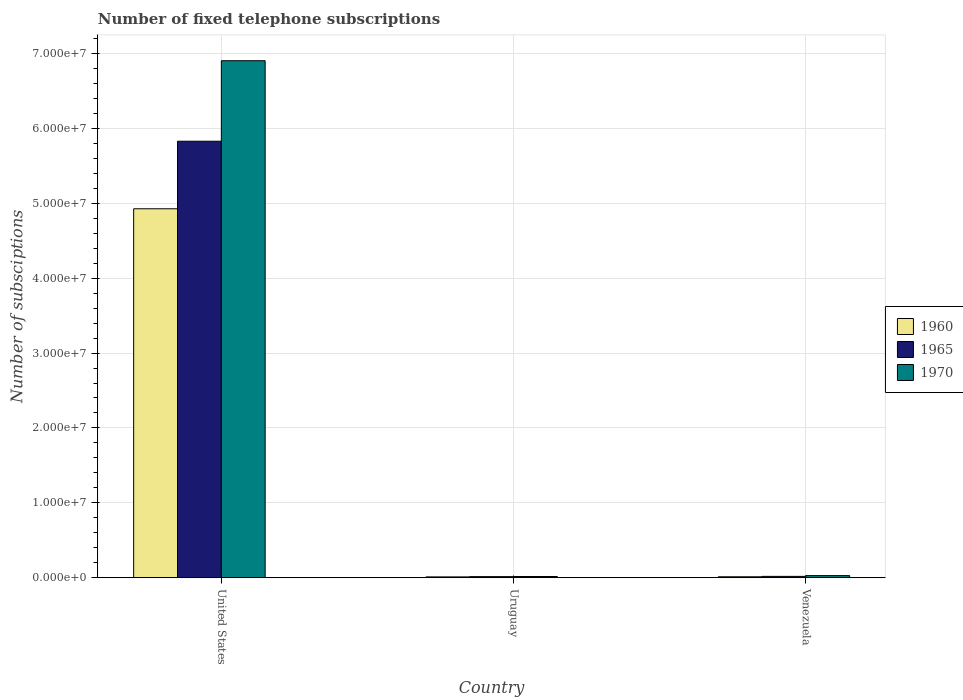How many different coloured bars are there?
Your answer should be very brief. 3. Are the number of bars per tick equal to the number of legend labels?
Give a very brief answer. Yes. Are the number of bars on each tick of the X-axis equal?
Your response must be concise. Yes. How many bars are there on the 3rd tick from the right?
Provide a short and direct response. 3. What is the label of the 2nd group of bars from the left?
Your response must be concise. Uruguay. In how many cases, is the number of bars for a given country not equal to the number of legend labels?
Provide a short and direct response. 0. What is the number of fixed telephone subscriptions in 1965 in Venezuela?
Offer a very short reply. 1.78e+05. Across all countries, what is the maximum number of fixed telephone subscriptions in 1965?
Your response must be concise. 5.83e+07. Across all countries, what is the minimum number of fixed telephone subscriptions in 1970?
Provide a succinct answer. 1.60e+05. In which country was the number of fixed telephone subscriptions in 1965 maximum?
Provide a succinct answer. United States. In which country was the number of fixed telephone subscriptions in 1970 minimum?
Ensure brevity in your answer.  Uruguay. What is the total number of fixed telephone subscriptions in 1970 in the graph?
Your answer should be very brief. 6.95e+07. What is the difference between the number of fixed telephone subscriptions in 1960 in United States and that in Uruguay?
Ensure brevity in your answer.  4.92e+07. What is the difference between the number of fixed telephone subscriptions in 1960 in Venezuela and the number of fixed telephone subscriptions in 1970 in United States?
Offer a very short reply. -6.89e+07. What is the average number of fixed telephone subscriptions in 1960 per country?
Your response must be concise. 1.65e+07. What is the difference between the number of fixed telephone subscriptions of/in 1970 and number of fixed telephone subscriptions of/in 1965 in Venezuela?
Ensure brevity in your answer.  1.01e+05. In how many countries, is the number of fixed telephone subscriptions in 1965 greater than 56000000?
Give a very brief answer. 1. What is the ratio of the number of fixed telephone subscriptions in 1965 in Uruguay to that in Venezuela?
Keep it short and to the point. 0.8. What is the difference between the highest and the second highest number of fixed telephone subscriptions in 1960?
Your answer should be compact. 4.91e+07. What is the difference between the highest and the lowest number of fixed telephone subscriptions in 1960?
Your answer should be very brief. 4.92e+07. What does the 2nd bar from the left in United States represents?
Offer a very short reply. 1965. What does the 3rd bar from the right in Venezuela represents?
Offer a terse response. 1960. Is it the case that in every country, the sum of the number of fixed telephone subscriptions in 1970 and number of fixed telephone subscriptions in 1960 is greater than the number of fixed telephone subscriptions in 1965?
Your answer should be very brief. Yes. How many countries are there in the graph?
Keep it short and to the point. 3. Are the values on the major ticks of Y-axis written in scientific E-notation?
Keep it short and to the point. Yes. Where does the legend appear in the graph?
Your answer should be compact. Center right. What is the title of the graph?
Your response must be concise. Number of fixed telephone subscriptions. Does "2002" appear as one of the legend labels in the graph?
Your answer should be very brief. No. What is the label or title of the X-axis?
Your answer should be very brief. Country. What is the label or title of the Y-axis?
Provide a succinct answer. Number of subsciptions. What is the Number of subsciptions in 1960 in United States?
Your response must be concise. 4.93e+07. What is the Number of subsciptions of 1965 in United States?
Keep it short and to the point. 5.83e+07. What is the Number of subsciptions in 1970 in United States?
Offer a very short reply. 6.90e+07. What is the Number of subsciptions of 1960 in Uruguay?
Ensure brevity in your answer.  1.10e+05. What is the Number of subsciptions of 1965 in Uruguay?
Ensure brevity in your answer.  1.42e+05. What is the Number of subsciptions of 1970 in Uruguay?
Ensure brevity in your answer.  1.60e+05. What is the Number of subsciptions in 1960 in Venezuela?
Your answer should be very brief. 1.25e+05. What is the Number of subsciptions in 1965 in Venezuela?
Offer a very short reply. 1.78e+05. What is the Number of subsciptions of 1970 in Venezuela?
Offer a terse response. 2.79e+05. Across all countries, what is the maximum Number of subsciptions of 1960?
Provide a short and direct response. 4.93e+07. Across all countries, what is the maximum Number of subsciptions of 1965?
Ensure brevity in your answer.  5.83e+07. Across all countries, what is the maximum Number of subsciptions in 1970?
Ensure brevity in your answer.  6.90e+07. Across all countries, what is the minimum Number of subsciptions in 1960?
Ensure brevity in your answer.  1.10e+05. Across all countries, what is the minimum Number of subsciptions of 1965?
Provide a succinct answer. 1.42e+05. What is the total Number of subsciptions in 1960 in the graph?
Your answer should be very brief. 4.95e+07. What is the total Number of subsciptions in 1965 in the graph?
Provide a short and direct response. 5.86e+07. What is the total Number of subsciptions in 1970 in the graph?
Provide a short and direct response. 6.95e+07. What is the difference between the Number of subsciptions of 1960 in United States and that in Uruguay?
Provide a short and direct response. 4.92e+07. What is the difference between the Number of subsciptions in 1965 in United States and that in Uruguay?
Provide a succinct answer. 5.81e+07. What is the difference between the Number of subsciptions of 1970 in United States and that in Uruguay?
Your response must be concise. 6.89e+07. What is the difference between the Number of subsciptions in 1960 in United States and that in Venezuela?
Offer a terse response. 4.91e+07. What is the difference between the Number of subsciptions in 1965 in United States and that in Venezuela?
Offer a very short reply. 5.81e+07. What is the difference between the Number of subsciptions of 1970 in United States and that in Venezuela?
Give a very brief answer. 6.88e+07. What is the difference between the Number of subsciptions in 1960 in Uruguay and that in Venezuela?
Your response must be concise. -1.50e+04. What is the difference between the Number of subsciptions of 1965 in Uruguay and that in Venezuela?
Offer a very short reply. -3.60e+04. What is the difference between the Number of subsciptions in 1970 in Uruguay and that in Venezuela?
Offer a very short reply. -1.19e+05. What is the difference between the Number of subsciptions in 1960 in United States and the Number of subsciptions in 1965 in Uruguay?
Provide a short and direct response. 4.91e+07. What is the difference between the Number of subsciptions of 1960 in United States and the Number of subsciptions of 1970 in Uruguay?
Your response must be concise. 4.91e+07. What is the difference between the Number of subsciptions in 1965 in United States and the Number of subsciptions in 1970 in Uruguay?
Your answer should be compact. 5.81e+07. What is the difference between the Number of subsciptions of 1960 in United States and the Number of subsciptions of 1965 in Venezuela?
Offer a very short reply. 4.91e+07. What is the difference between the Number of subsciptions in 1960 in United States and the Number of subsciptions in 1970 in Venezuela?
Give a very brief answer. 4.90e+07. What is the difference between the Number of subsciptions of 1965 in United States and the Number of subsciptions of 1970 in Venezuela?
Your answer should be compact. 5.80e+07. What is the difference between the Number of subsciptions of 1960 in Uruguay and the Number of subsciptions of 1965 in Venezuela?
Offer a terse response. -6.80e+04. What is the difference between the Number of subsciptions in 1960 in Uruguay and the Number of subsciptions in 1970 in Venezuela?
Offer a very short reply. -1.69e+05. What is the difference between the Number of subsciptions in 1965 in Uruguay and the Number of subsciptions in 1970 in Venezuela?
Give a very brief answer. -1.37e+05. What is the average Number of subsciptions in 1960 per country?
Keep it short and to the point. 1.65e+07. What is the average Number of subsciptions in 1965 per country?
Offer a terse response. 1.95e+07. What is the average Number of subsciptions in 1970 per country?
Offer a very short reply. 2.32e+07. What is the difference between the Number of subsciptions of 1960 and Number of subsciptions of 1965 in United States?
Make the answer very short. -9.02e+06. What is the difference between the Number of subsciptions in 1960 and Number of subsciptions in 1970 in United States?
Offer a very short reply. -1.98e+07. What is the difference between the Number of subsciptions of 1965 and Number of subsciptions of 1970 in United States?
Your answer should be very brief. -1.08e+07. What is the difference between the Number of subsciptions of 1960 and Number of subsciptions of 1965 in Uruguay?
Provide a succinct answer. -3.20e+04. What is the difference between the Number of subsciptions in 1960 and Number of subsciptions in 1970 in Uruguay?
Ensure brevity in your answer.  -5.00e+04. What is the difference between the Number of subsciptions of 1965 and Number of subsciptions of 1970 in Uruguay?
Offer a terse response. -1.80e+04. What is the difference between the Number of subsciptions of 1960 and Number of subsciptions of 1965 in Venezuela?
Your answer should be very brief. -5.30e+04. What is the difference between the Number of subsciptions of 1960 and Number of subsciptions of 1970 in Venezuela?
Your answer should be compact. -1.54e+05. What is the difference between the Number of subsciptions of 1965 and Number of subsciptions of 1970 in Venezuela?
Give a very brief answer. -1.01e+05. What is the ratio of the Number of subsciptions of 1960 in United States to that in Uruguay?
Offer a terse response. 447.9. What is the ratio of the Number of subsciptions of 1965 in United States to that in Uruguay?
Keep it short and to the point. 410.49. What is the ratio of the Number of subsciptions of 1970 in United States to that in Uruguay?
Your response must be concise. 431.49. What is the ratio of the Number of subsciptions of 1960 in United States to that in Venezuela?
Give a very brief answer. 394.15. What is the ratio of the Number of subsciptions of 1965 in United States to that in Venezuela?
Give a very brief answer. 327.47. What is the ratio of the Number of subsciptions of 1970 in United States to that in Venezuela?
Provide a short and direct response. 247.45. What is the ratio of the Number of subsciptions in 1960 in Uruguay to that in Venezuela?
Offer a terse response. 0.88. What is the ratio of the Number of subsciptions in 1965 in Uruguay to that in Venezuela?
Keep it short and to the point. 0.8. What is the ratio of the Number of subsciptions of 1970 in Uruguay to that in Venezuela?
Give a very brief answer. 0.57. What is the difference between the highest and the second highest Number of subsciptions of 1960?
Your answer should be compact. 4.91e+07. What is the difference between the highest and the second highest Number of subsciptions of 1965?
Give a very brief answer. 5.81e+07. What is the difference between the highest and the second highest Number of subsciptions of 1970?
Keep it short and to the point. 6.88e+07. What is the difference between the highest and the lowest Number of subsciptions of 1960?
Give a very brief answer. 4.92e+07. What is the difference between the highest and the lowest Number of subsciptions of 1965?
Your answer should be very brief. 5.81e+07. What is the difference between the highest and the lowest Number of subsciptions of 1970?
Keep it short and to the point. 6.89e+07. 